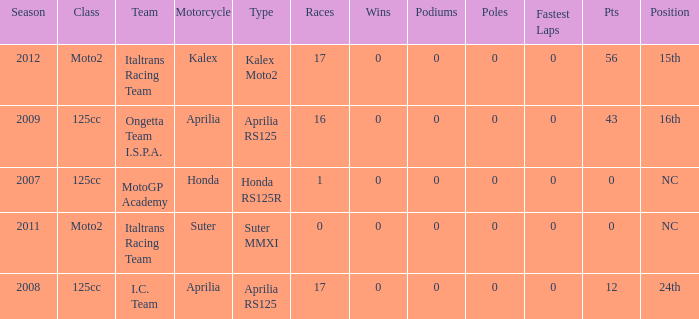What's the name of the team who had a Honda motorcycle? MotoGP Academy. 